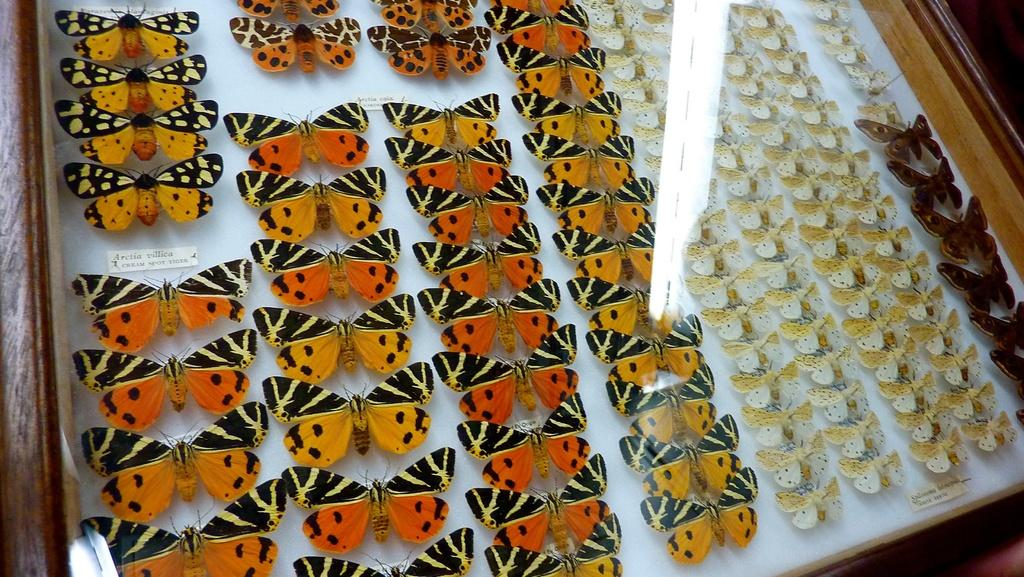What creatures can be seen in the image? There are butterflies in the image. Can you describe the butterflies in the image? The butterflies are of different types. Where are the butterflies located in the image? The butterflies are inside a glass box. What is the purpose of the planes in the image? There are no planes present in the image; it features butterflies inside a glass box. 